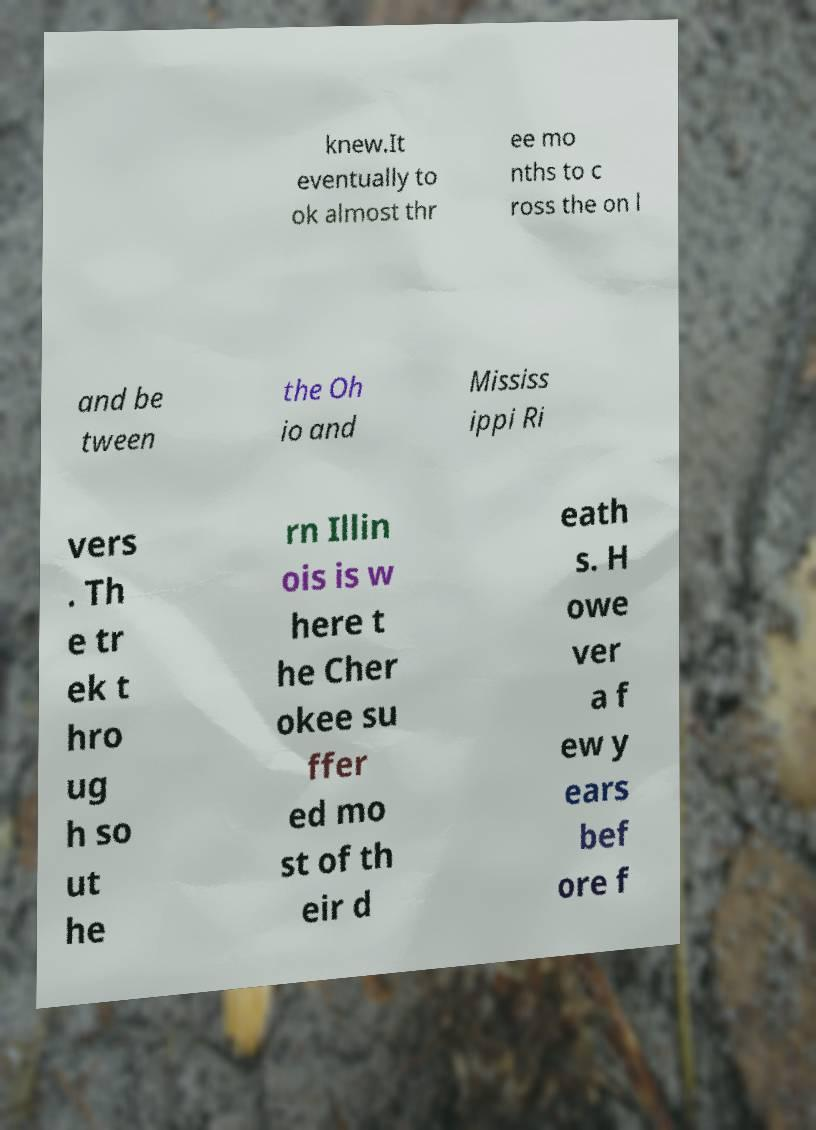Please identify and transcribe the text found in this image. knew.It eventually to ok almost thr ee mo nths to c ross the on l and be tween the Oh io and Mississ ippi Ri vers . Th e tr ek t hro ug h so ut he rn Illin ois is w here t he Cher okee su ffer ed mo st of th eir d eath s. H owe ver a f ew y ears bef ore f 